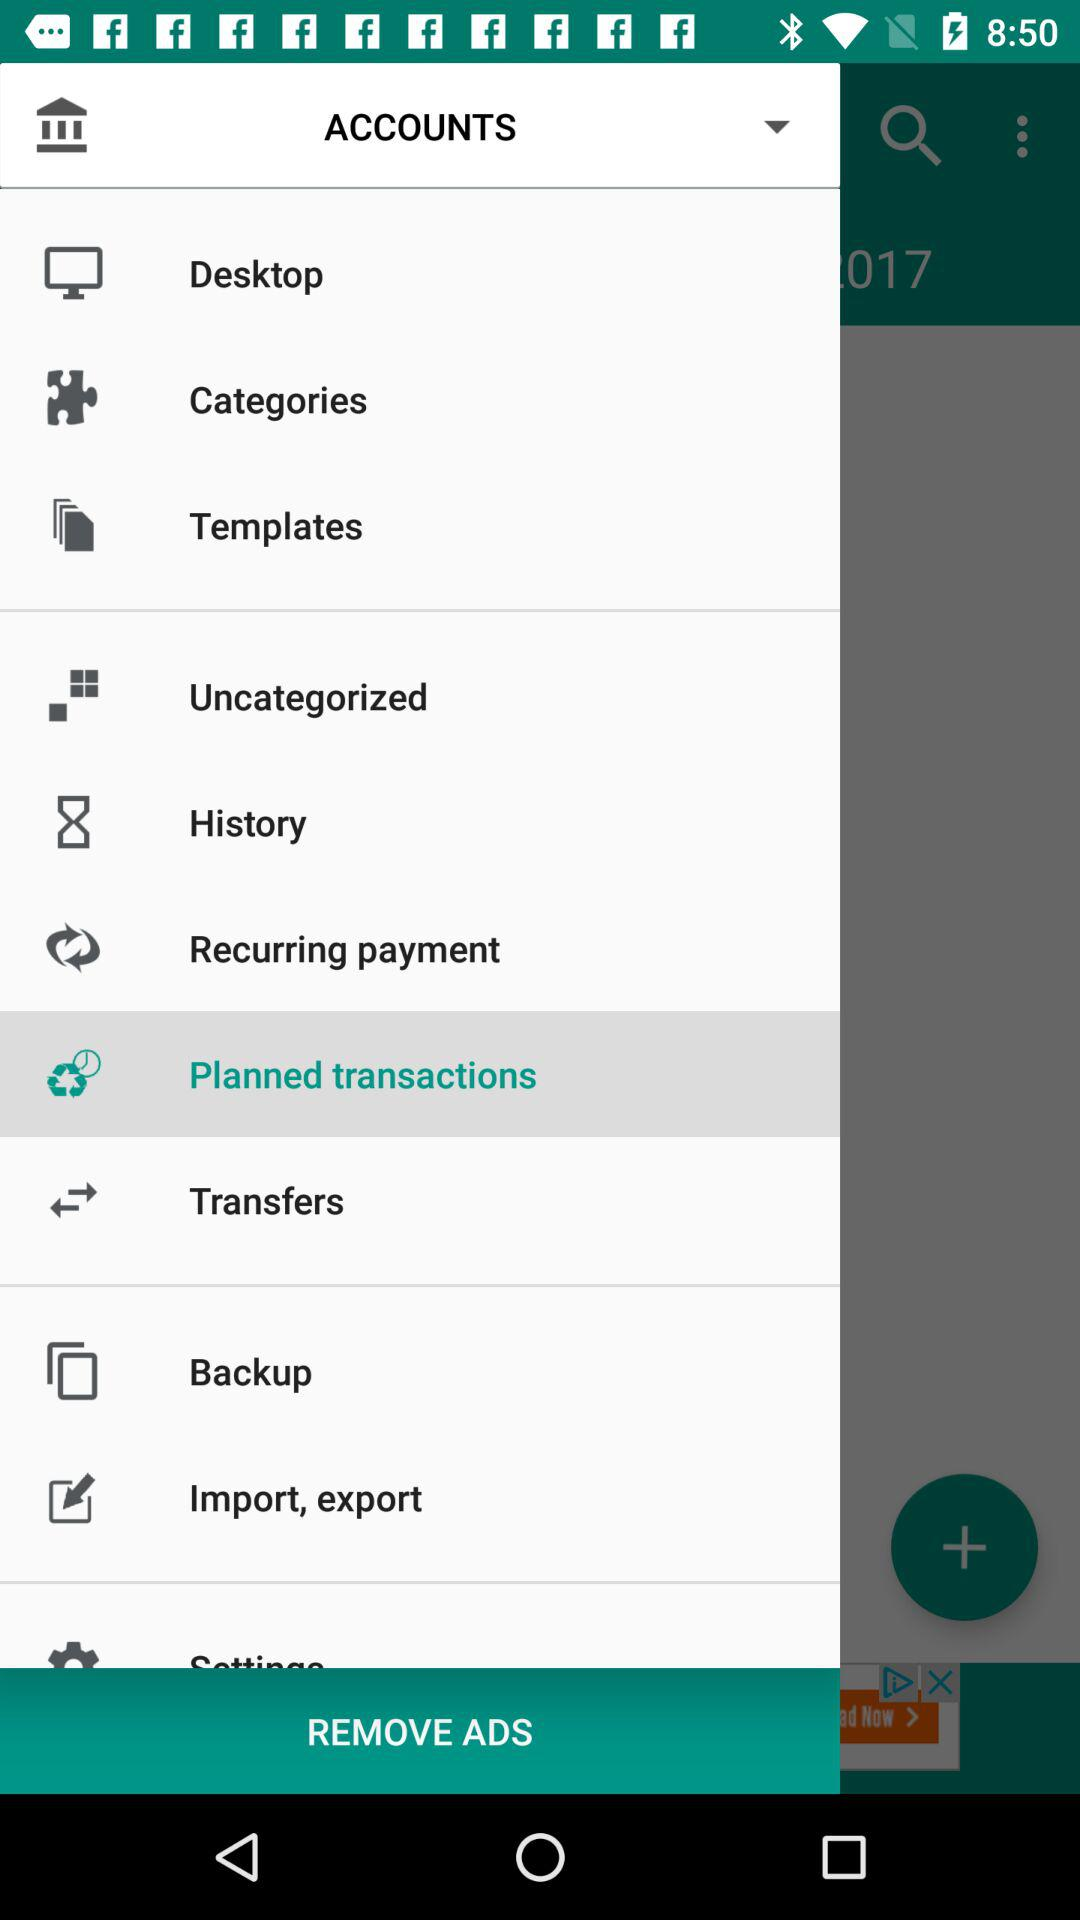What is the selected item? The selected item is "Planned transactions". 